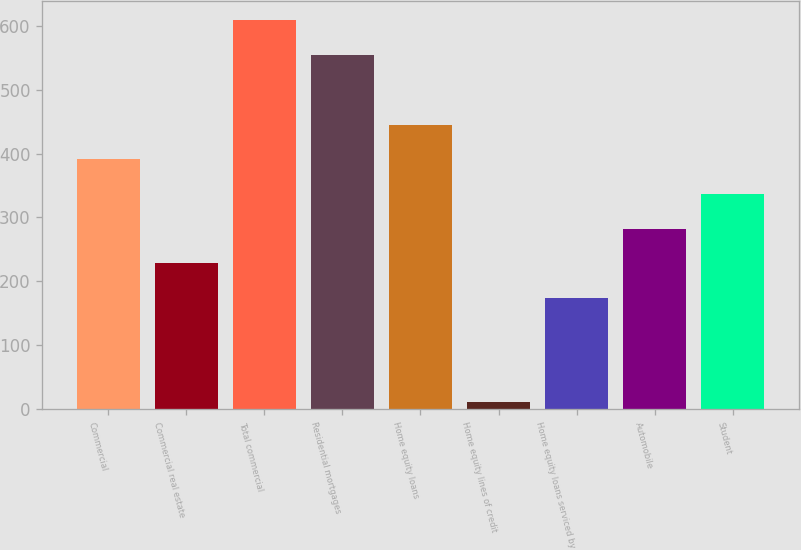Convert chart to OTSL. <chart><loc_0><loc_0><loc_500><loc_500><bar_chart><fcel>Commercial<fcel>Commercial real estate<fcel>Total commercial<fcel>Residential mortgages<fcel>Home equity loans<fcel>Home equity lines of credit<fcel>Home equity loans serviced by<fcel>Automobile<fcel>Student<nl><fcel>391.1<fcel>228.2<fcel>608.3<fcel>554<fcel>445.4<fcel>11<fcel>173.9<fcel>282.5<fcel>336.8<nl></chart> 